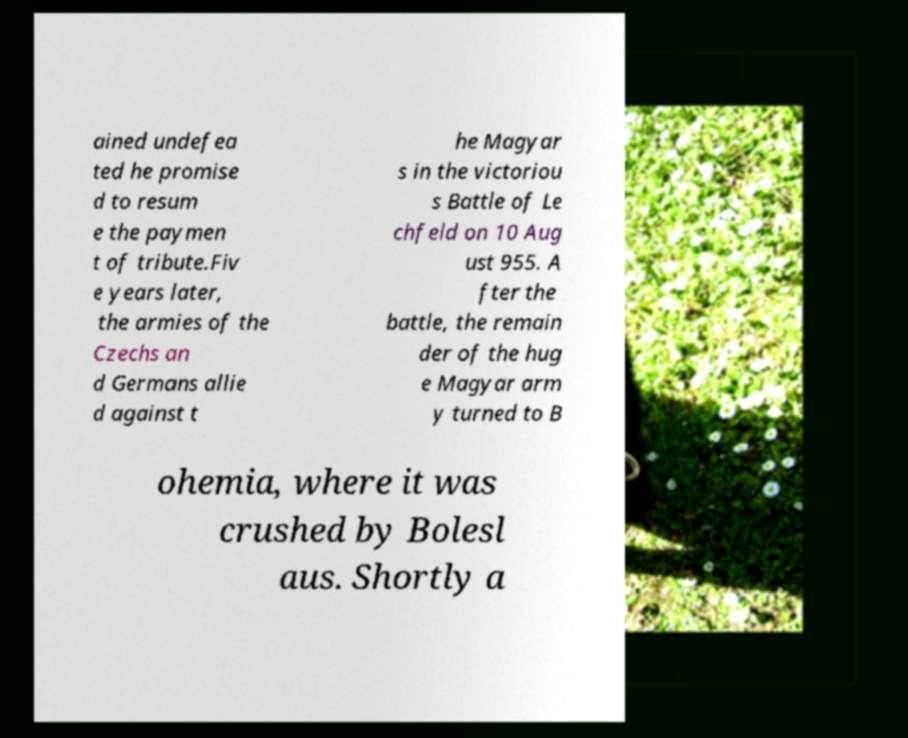Could you extract and type out the text from this image? ained undefea ted he promise d to resum e the paymen t of tribute.Fiv e years later, the armies of the Czechs an d Germans allie d against t he Magyar s in the victoriou s Battle of Le chfeld on 10 Aug ust 955. A fter the battle, the remain der of the hug e Magyar arm y turned to B ohemia, where it was crushed by Bolesl aus. Shortly a 